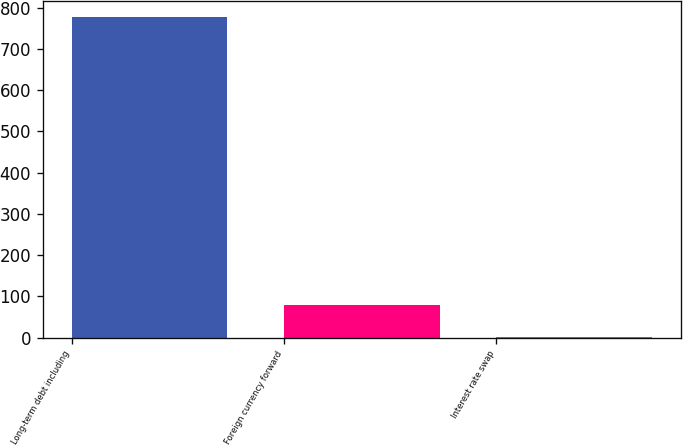Convert chart to OTSL. <chart><loc_0><loc_0><loc_500><loc_500><bar_chart><fcel>Long-term debt including<fcel>Foreign currency forward<fcel>Interest rate swap<nl><fcel>777.3<fcel>79.35<fcel>1.8<nl></chart> 